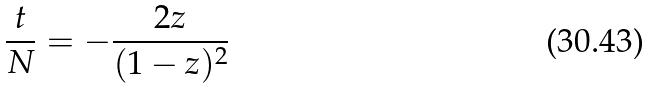<formula> <loc_0><loc_0><loc_500><loc_500>\frac { t } { N } = - \frac { 2 z } { ( 1 - z ) ^ { 2 } }</formula> 